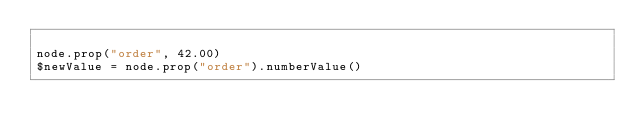Convert code to text. <code><loc_0><loc_0><loc_500><loc_500><_Ruby_>
node.prop("order", 42.00)
$newValue = node.prop("order").numberValue()</code> 